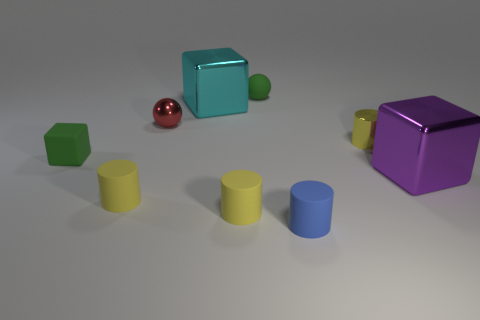Subtract all purple cubes. How many yellow cylinders are left? 3 Add 1 big cubes. How many objects exist? 10 Subtract all blocks. How many objects are left? 6 Subtract all metal cylinders. Subtract all tiny blue rubber cylinders. How many objects are left? 7 Add 6 metallic cylinders. How many metallic cylinders are left? 7 Add 5 cylinders. How many cylinders exist? 9 Subtract 0 brown blocks. How many objects are left? 9 